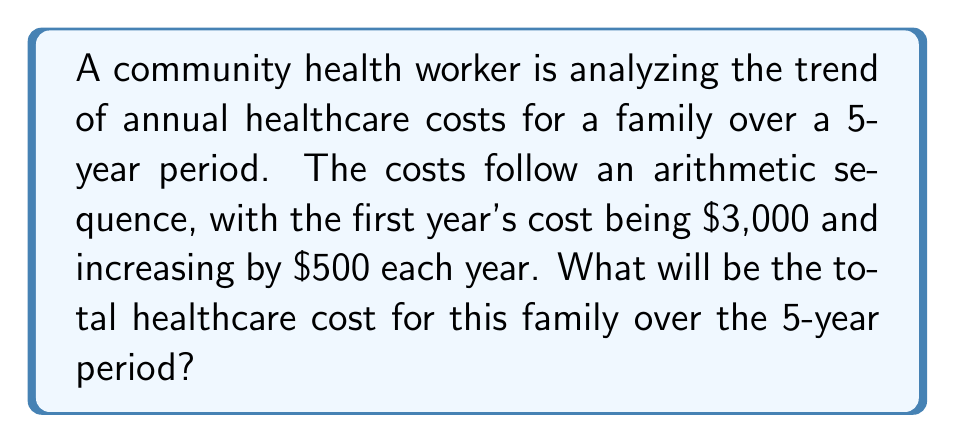Solve this math problem. Let's approach this step-by-step:

1) First, we need to identify the arithmetic sequence:
   - First term (a₁) = $3,000
   - Common difference (d) = $500

2) The sequence of healthcare costs will be:
   Year 1: $3,000
   Year 2: $3,500
   Year 3: $4,000
   Year 4: $4,500
   Year 5: $5,000

3) To find the total cost, we need to sum this sequence. We can use the arithmetic sequence sum formula:

   $$S_n = \frac{n}{2}(a_1 + a_n)$$

   Where:
   $S_n$ is the sum of the sequence
   $n$ is the number of terms (5 in this case)
   $a_1$ is the first term ($3,000)
   $a_n$ is the last term ($5,000)

4) Plugging in the values:

   $$S_5 = \frac{5}{2}(3000 + 5000)$$

5) Simplifying:
   $$S_5 = \frac{5}{2}(8000) = 5 \times 4000 = 20000$$

Therefore, the total healthcare cost over the 5-year period will be $20,000.
Answer: $20,000 